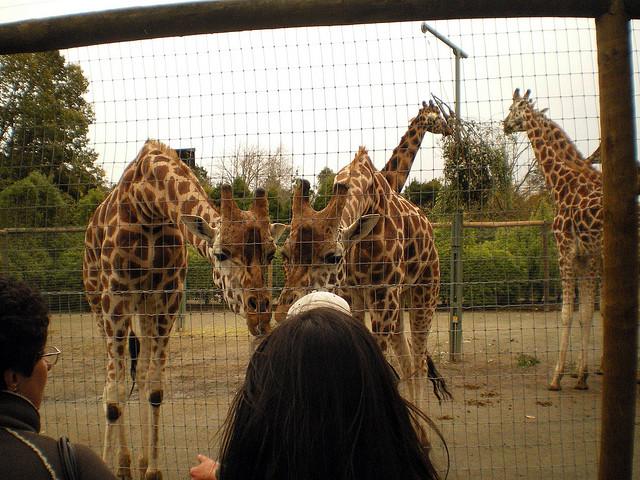Are the people feeding the giraffes?
Be succinct. Yes. Is the fence made of wood?
Give a very brief answer. No. Which person is wearing glasses?
Write a very short answer. Person on left. How many giraffes are there?
Keep it brief. 4. 